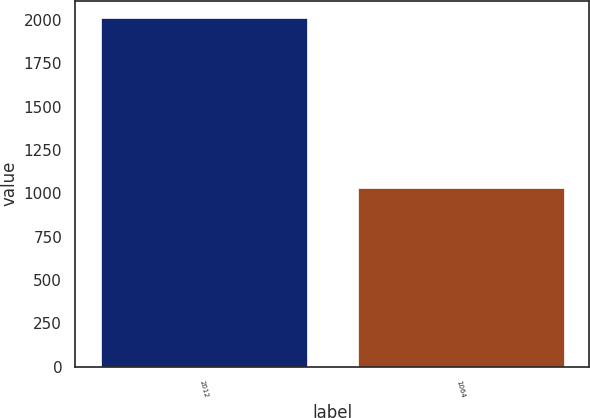Convert chart to OTSL. <chart><loc_0><loc_0><loc_500><loc_500><bar_chart><fcel>2012<fcel>1064<nl><fcel>2011<fcel>1031<nl></chart> 